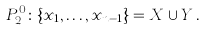<formula> <loc_0><loc_0><loc_500><loc_500>P _ { 2 } ^ { 0 } \colon \{ x _ { 1 } , \dots , x _ { n - 1 } \} = X \cup Y \, .</formula> 